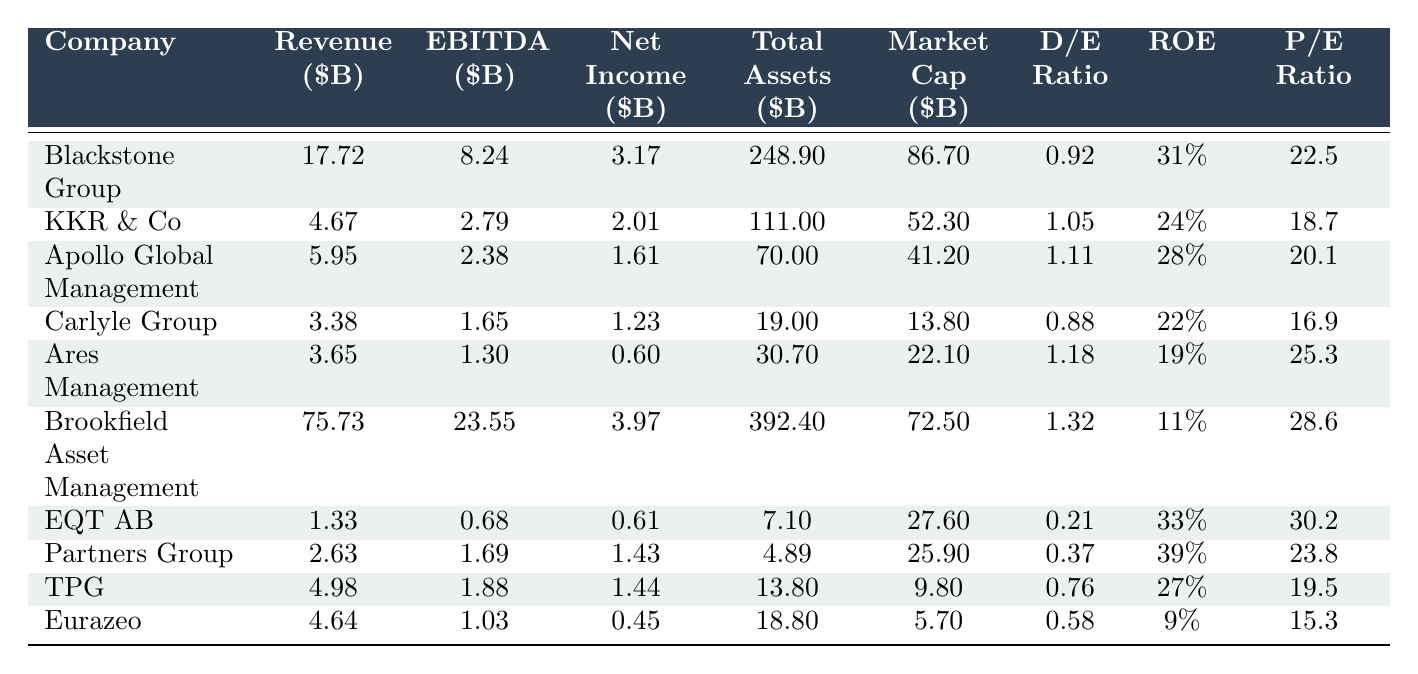What is the revenue of Blackstone Group? Blackstone Group's revenue is listed in the table as $17.72 billion.
Answer: 17.72 billion Which company has the highest net income? By comparing the net income values, Blackstone Group has the highest net income at $3.17 billion.
Answer: Blackstone Group What is the market capitalization of Ares Management? Ares Management's market capitalization is shown in the table as $22.10 billion.
Answer: 22.10 billion Which company has the lowest debt-to-equity ratio? Looking at the debt-to-equity ratios, EQT AB has the lowest ratio at 0.21.
Answer: EQT AB What is the average revenue of the top 10 companies? To calculate the average revenue, sum the revenues: 17.72 + 4.67 + 5.95 + 3.38 + 3.65 + 75.73 + 1.33 + 2.63 + 4.98 + 4.64 = 119.66 billion. Then divide by 10 to get 11.966 billion.
Answer: 11.97 billion Is the ROE of Brookfield Asset Management greater than 15%? Brookfield Asset Management's ROE is 11%, which is less than 15%.
Answer: No How much is the difference between the total assets of Brookfield Asset Management and Carlyle Group? The difference in total assets is calculated as 392.40 - 19.00 = 373.40 billion.
Answer: 373.40 billion What percentage of revenue is represented by Apollo Global Management's net income? Apollo Global Management's net income is $1.61 billion, and its revenue is $5.95 billion. The percentage is (1.61 / 5.95) * 100 = 27.03%.
Answer: 27.03% Which company has the highest P/E ratio and what is that ratio? After checking the P/E ratios, EQT AB has the highest P/E ratio of 30.2.
Answer: EQT AB, 30.2 If we compare the total assets of KKR & Co and Eurazeo, which company has more total assets? KKR & Co has $111.00 billion in total assets, while Eurazeo has $18.80 billion. Therefore, KKR & Co has more total assets.
Answer: KKR & Co 